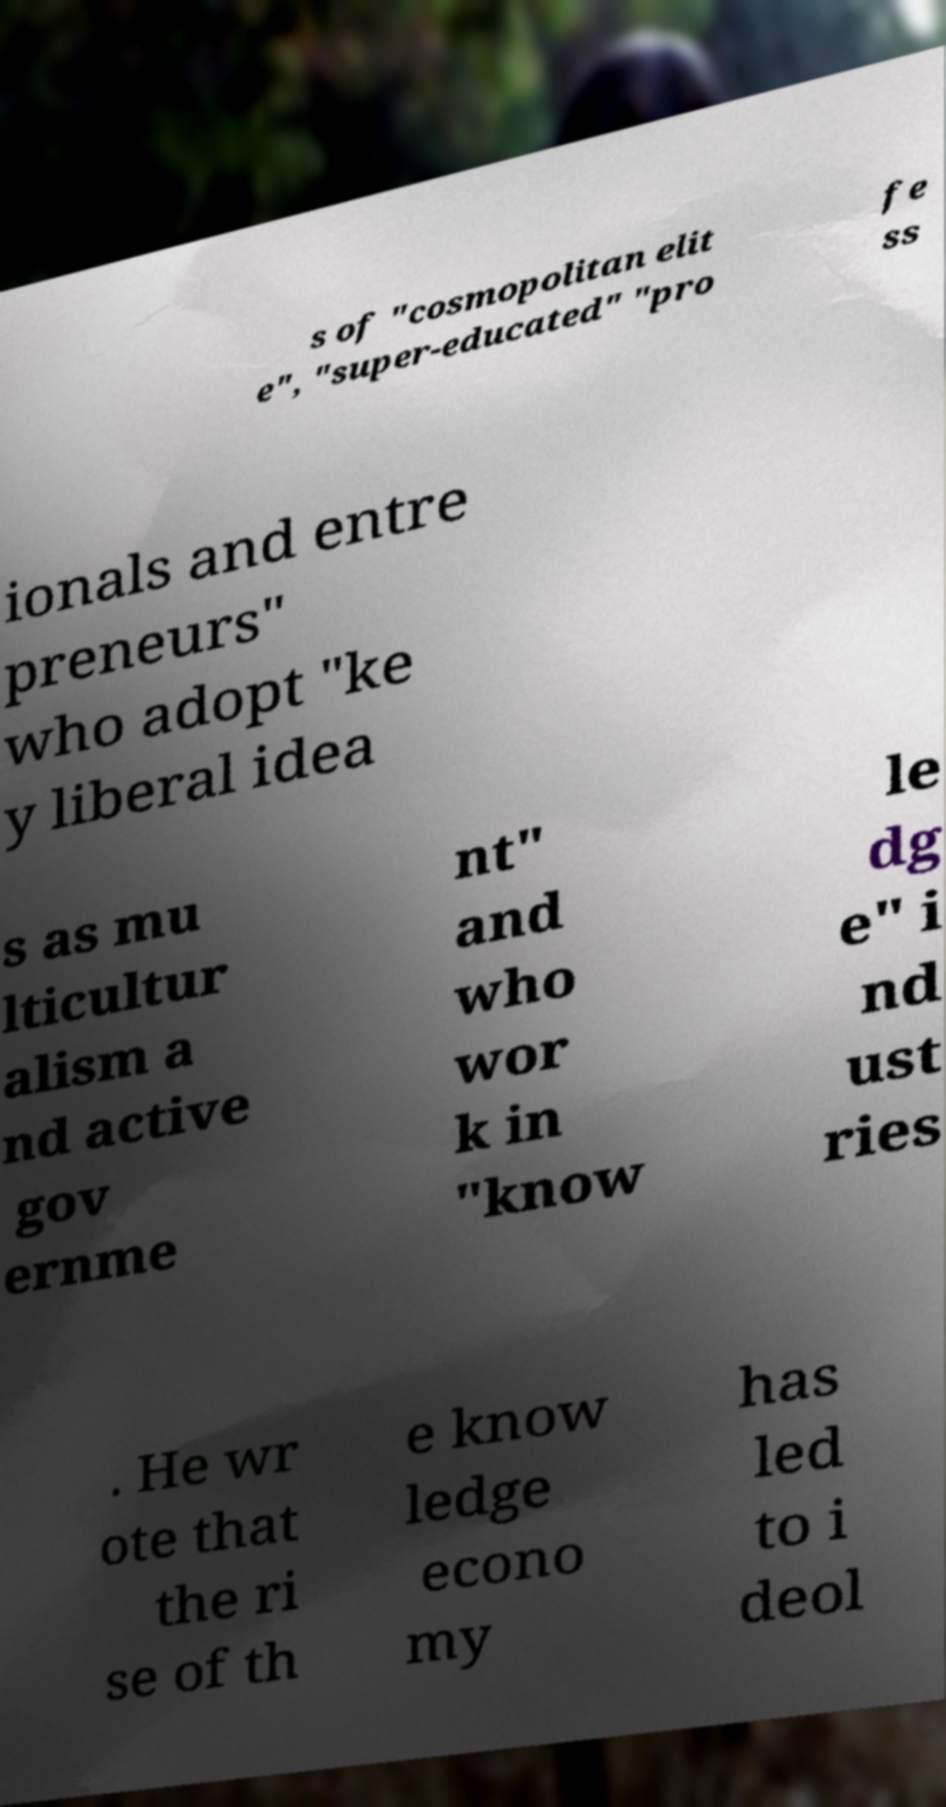Can you read and provide the text displayed in the image?This photo seems to have some interesting text. Can you extract and type it out for me? s of "cosmopolitan elit e", "super-educated" "pro fe ss ionals and entre preneurs" who adopt "ke y liberal idea s as mu lticultur alism a nd active gov ernme nt" and who wor k in "know le dg e" i nd ust ries . He wr ote that the ri se of th e know ledge econo my has led to i deol 